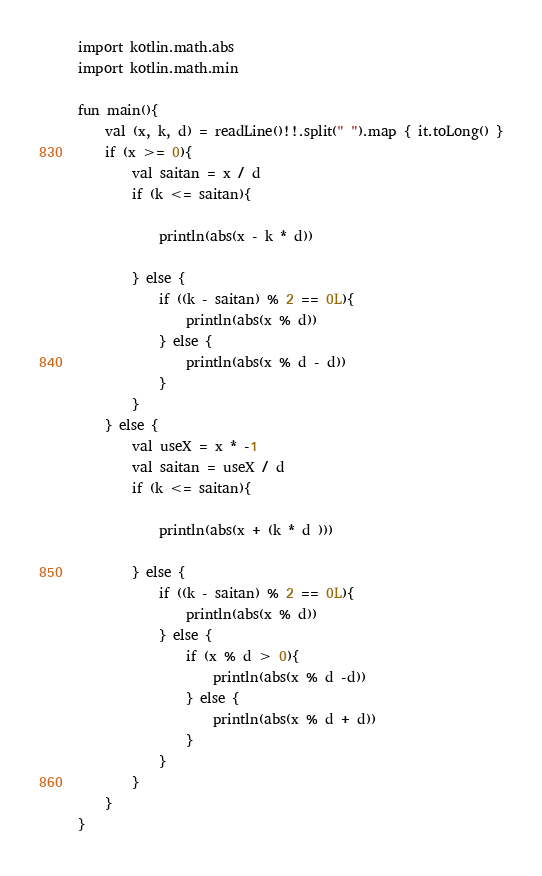Convert code to text. <code><loc_0><loc_0><loc_500><loc_500><_Kotlin_>import kotlin.math.abs
import kotlin.math.min

fun main(){
    val (x, k, d) = readLine()!!.split(" ").map { it.toLong() }
    if (x >= 0){
        val saitan = x / d
        if (k <= saitan){

            println(abs(x - k * d))

        } else {
            if ((k - saitan) % 2 == 0L){
                println(abs(x % d))
            } else {
                println(abs(x % d - d))
            }
        }
    } else {
        val useX = x * -1
        val saitan = useX / d
        if (k <= saitan){

            println(abs(x + (k * d )))

        } else {
            if ((k - saitan) % 2 == 0L){
                println(abs(x % d))
            } else {
                if (x % d > 0){
                    println(abs(x % d -d))
                } else {
                    println(abs(x % d + d))
                }
            }
        }
    }
}</code> 